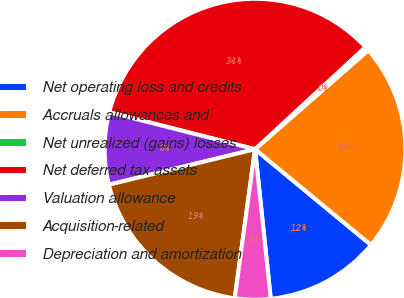<chart> <loc_0><loc_0><loc_500><loc_500><pie_chart><fcel>Net operating loss and credits<fcel>Accruals allowances and<fcel>Net unrealized (gains) losses<fcel>Net deferred tax assets<fcel>Valuation allowance<fcel>Acquisition-related<fcel>Depreciation and amortization<nl><fcel>12.35%<fcel>22.42%<fcel>0.45%<fcel>34.16%<fcel>7.75%<fcel>19.05%<fcel>3.82%<nl></chart> 